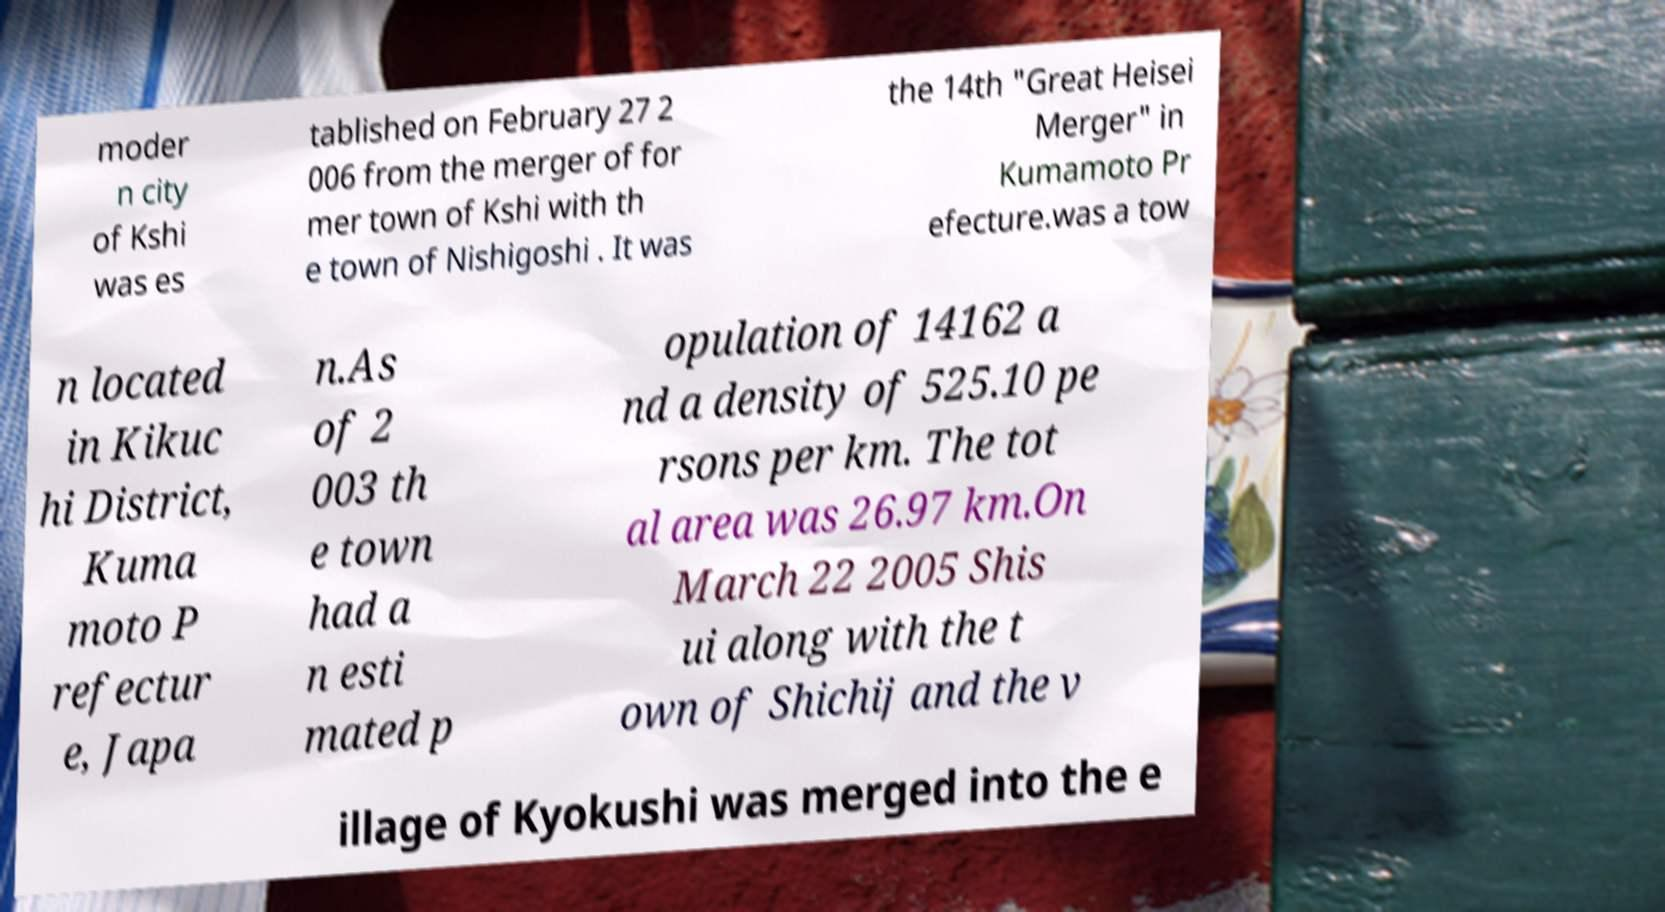What messages or text are displayed in this image? I need them in a readable, typed format. moder n city of Kshi was es tablished on February 27 2 006 from the merger of for mer town of Kshi with th e town of Nishigoshi . It was the 14th "Great Heisei Merger" in Kumamoto Pr efecture.was a tow n located in Kikuc hi District, Kuma moto P refectur e, Japa n.As of 2 003 th e town had a n esti mated p opulation of 14162 a nd a density of 525.10 pe rsons per km. The tot al area was 26.97 km.On March 22 2005 Shis ui along with the t own of Shichij and the v illage of Kyokushi was merged into the e 